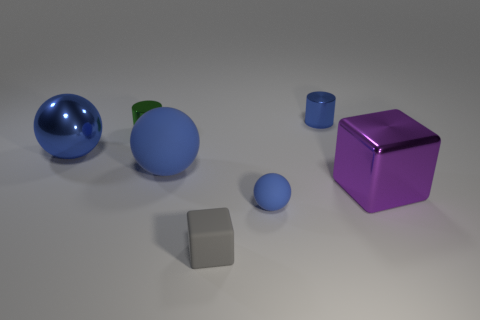Add 1 purple rubber objects. How many objects exist? 8 Subtract all cylinders. How many objects are left? 5 Subtract all shiny things. Subtract all green shiny cylinders. How many objects are left? 2 Add 5 metallic cubes. How many metallic cubes are left? 6 Add 2 big green matte objects. How many big green matte objects exist? 2 Subtract 2 blue balls. How many objects are left? 5 